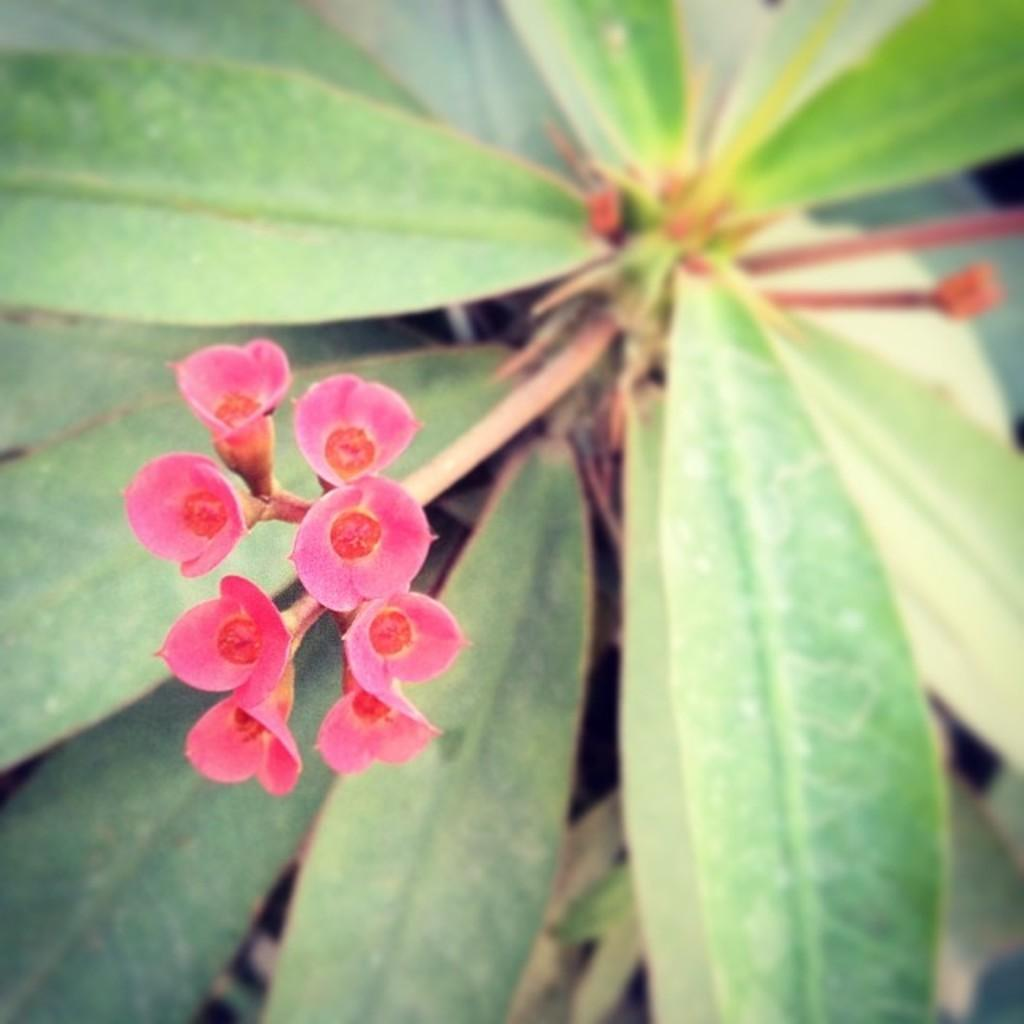What type of living organism is present in the image? There is a plant in the image. What specific features can be observed on the plant? The plant has flowers and leaves. How long has the plant been sleeping in the image? Plants do not sleep, so this question cannot be answered. 